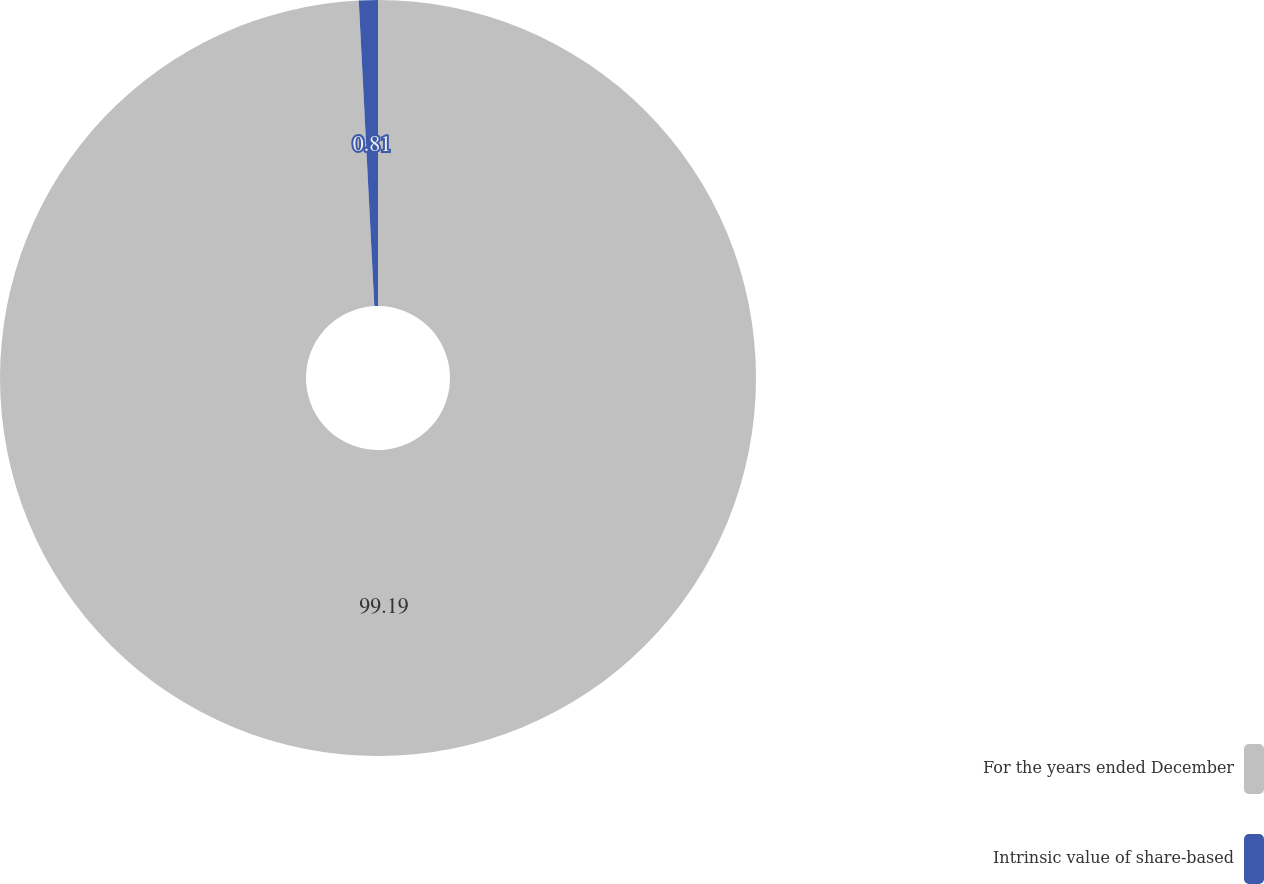Convert chart to OTSL. <chart><loc_0><loc_0><loc_500><loc_500><pie_chart><fcel>For the years ended December<fcel>Intrinsic value of share-based<nl><fcel>99.19%<fcel>0.81%<nl></chart> 